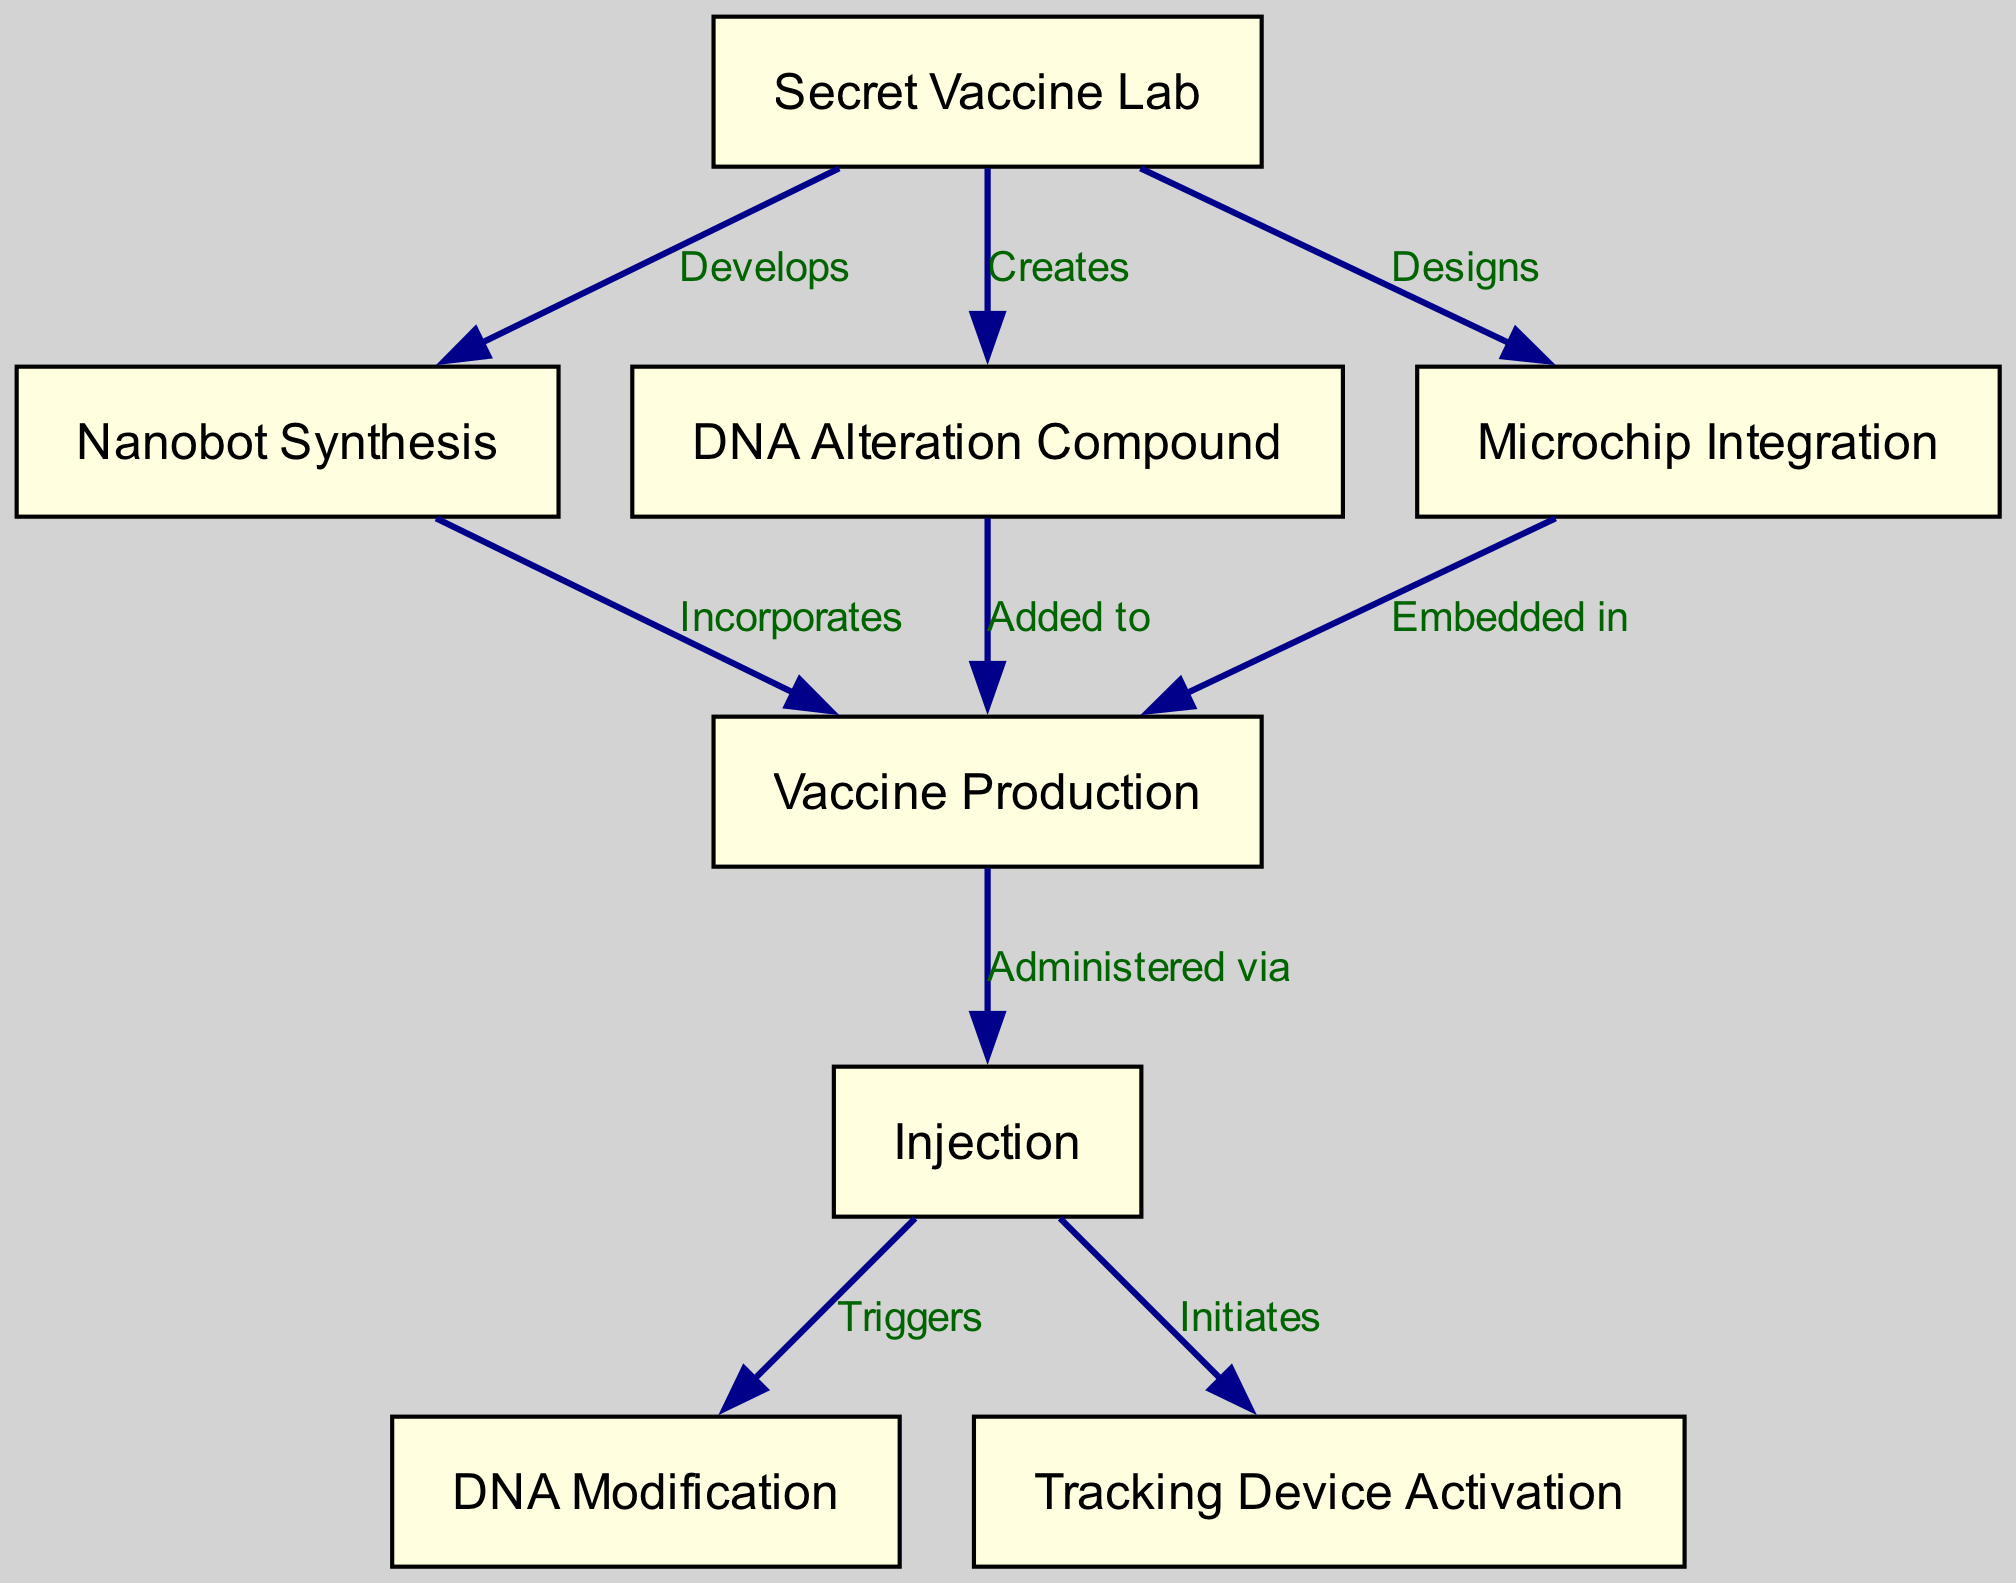What is the first node in the flow chart? The first node in the diagram is represented by the label “Secret Vaccine Lab.” It indicates the starting point of the process outlined in the flow chart.
Answer: Secret Vaccine Lab How many nodes are there in total? By counting each unique labeled node in the diagram, we find that there are eight nodes represented, each highlighting a different step in the process.
Answer: 8 What relationship exists between "Secret Vaccine Lab" and "Vaccine Production"? The edge between these two nodes shows that the "Secret Vaccine Lab" is responsible for creating components — specifically, the lab "Creates" a DNA Alteration Compound, which is "Added to" the Vaccine in the subsequent steps.
Answer: Creates & Added to Which node triggers DNA Modification? The node "Injection" triggers the "DNA Modification." When the vaccine is injected, this step signifies the activation of the DNA modification process.
Answer: Injection What is embedded in the Vaccine? The flow chart specifies that a "Microchip" is embedded in the vaccine. This is part of the processing that occurs at the "Vaccine Production" stage, linked from the "Microchip Integration."
Answer: Microchip How does the "Secret Vaccine Lab" contribute to the injection process? The "Secret Vaccine Lab" develops various components, including DNA alteration compounds and microchips, both of which are utilized in the "Vaccine Production." These elements are critical since they facilitate what happens during the "Injection." Thus, the lab plays a foundational role in the injection process.
Answer: Develops and Designs What activates the Tracking Device? The "Injection" node initiates the activation of the tracking device. According to the flow, once the vaccine is administered, it leads to the activation of a tracking device as the next step in the process.
Answer: Initiates What is synthesized in the lab according to the diagram? According to the flow chart, "Nanobots" are synthesized in the "Secret Vaccine Lab." This suggests that nanobot synthesis is one of the processes happening at the lab as part of the vaccine development procedure.
Answer: Nanobots How many edges connect "Injection" to subsequent processes? There are two edges that connect the "Injection" node to subsequent processes. One leads to "DNA Modification," and the other leads to "Tracking Device Activation." Each edge specifies a different outcome of the injection process.
Answer: 2 